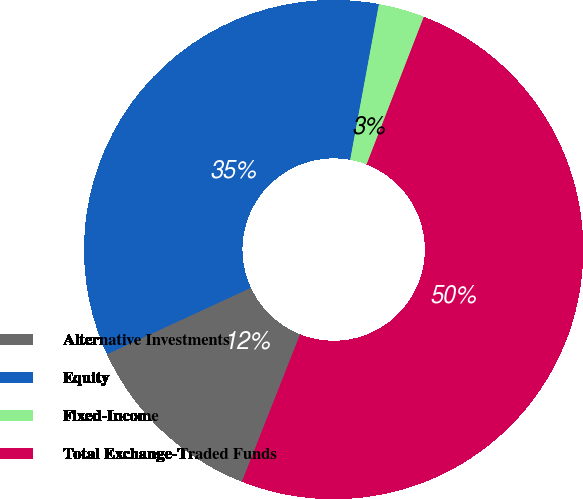<chart> <loc_0><loc_0><loc_500><loc_500><pie_chart><fcel>Alternative Investments<fcel>Equity<fcel>Fixed-Income<fcel>Total Exchange-Traded Funds<nl><fcel>12.13%<fcel>34.79%<fcel>2.98%<fcel>50.1%<nl></chart> 